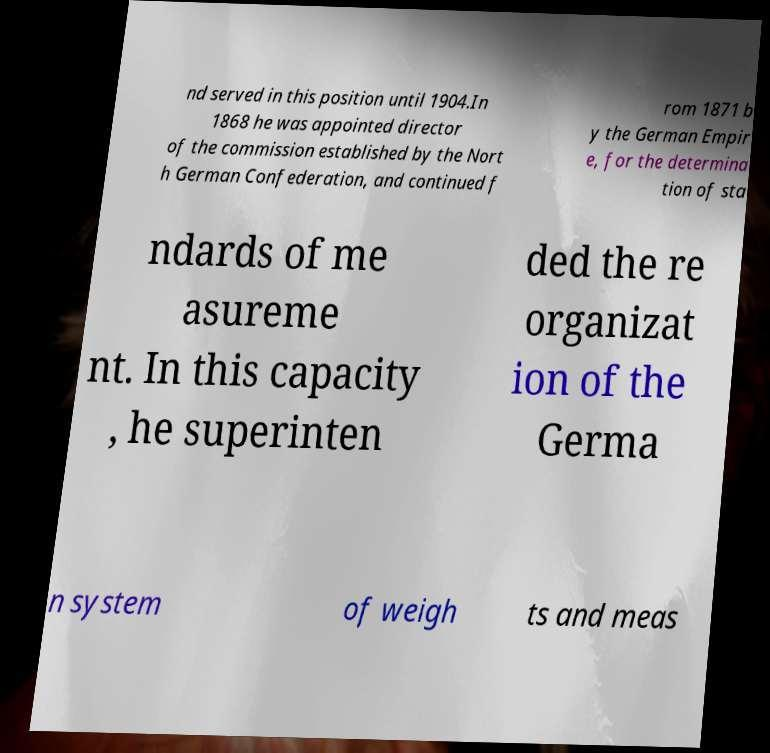Can you read and provide the text displayed in the image?This photo seems to have some interesting text. Can you extract and type it out for me? nd served in this position until 1904.In 1868 he was appointed director of the commission established by the Nort h German Confederation, and continued f rom 1871 b y the German Empir e, for the determina tion of sta ndards of me asureme nt. In this capacity , he superinten ded the re organizat ion of the Germa n system of weigh ts and meas 